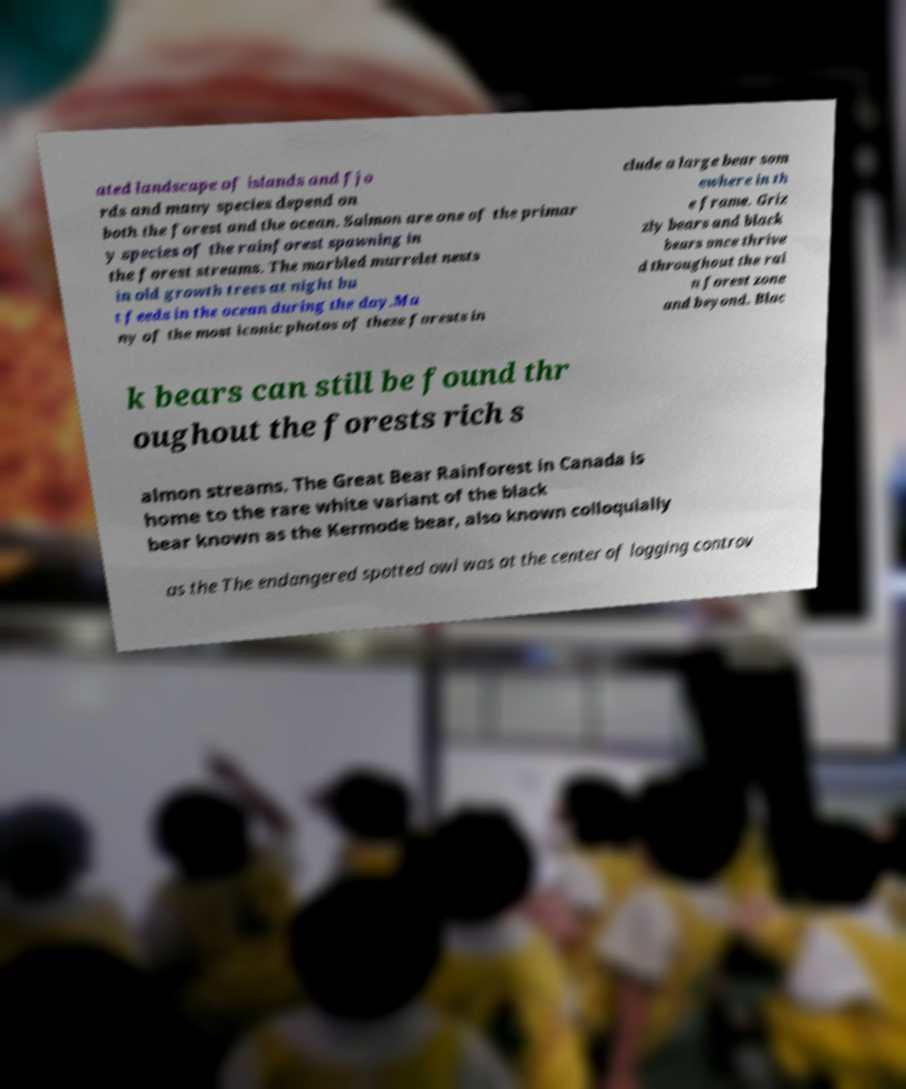What messages or text are displayed in this image? I need them in a readable, typed format. ated landscape of islands and fjo rds and many species depend on both the forest and the ocean. Salmon are one of the primar y species of the rainforest spawning in the forest streams. The marbled murrelet nests in old growth trees at night bu t feeds in the ocean during the day.Ma ny of the most iconic photos of these forests in clude a large bear som ewhere in th e frame. Griz zly bears and black bears once thrive d throughout the rai n forest zone and beyond. Blac k bears can still be found thr oughout the forests rich s almon streams. The Great Bear Rainforest in Canada is home to the rare white variant of the black bear known as the Kermode bear, also known colloquially as the The endangered spotted owl was at the center of logging controv 